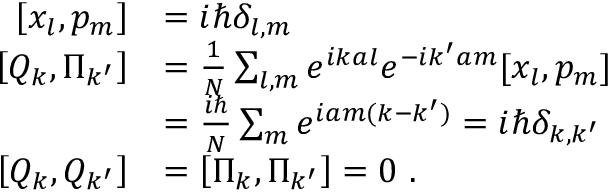<formula> <loc_0><loc_0><loc_500><loc_500>{ \begin{array} { r l } { \left [ x _ { l } , p _ { m } \right ] } & { = i \hbar { \delta } _ { l , m } } \\ { \left [ Q _ { k } , \Pi _ { k ^ { \prime } } \right ] } & { = { \frac { 1 } { N } } \sum _ { l , m } e ^ { i k a l } e ^ { - i k ^ { \prime } a m } [ x _ { l } , p _ { m } ] } \\ & { = { \frac { i } { N } } \sum _ { m } e ^ { i a m ( k - k ^ { \prime } ) } = i \hbar { \delta } _ { k , k ^ { \prime } } } \\ { \left [ Q _ { k } , Q _ { k ^ { \prime } } \right ] } & { = \left [ \Pi _ { k } , \Pi _ { k ^ { \prime } } \right ] = 0 . } \end{array} }</formula> 